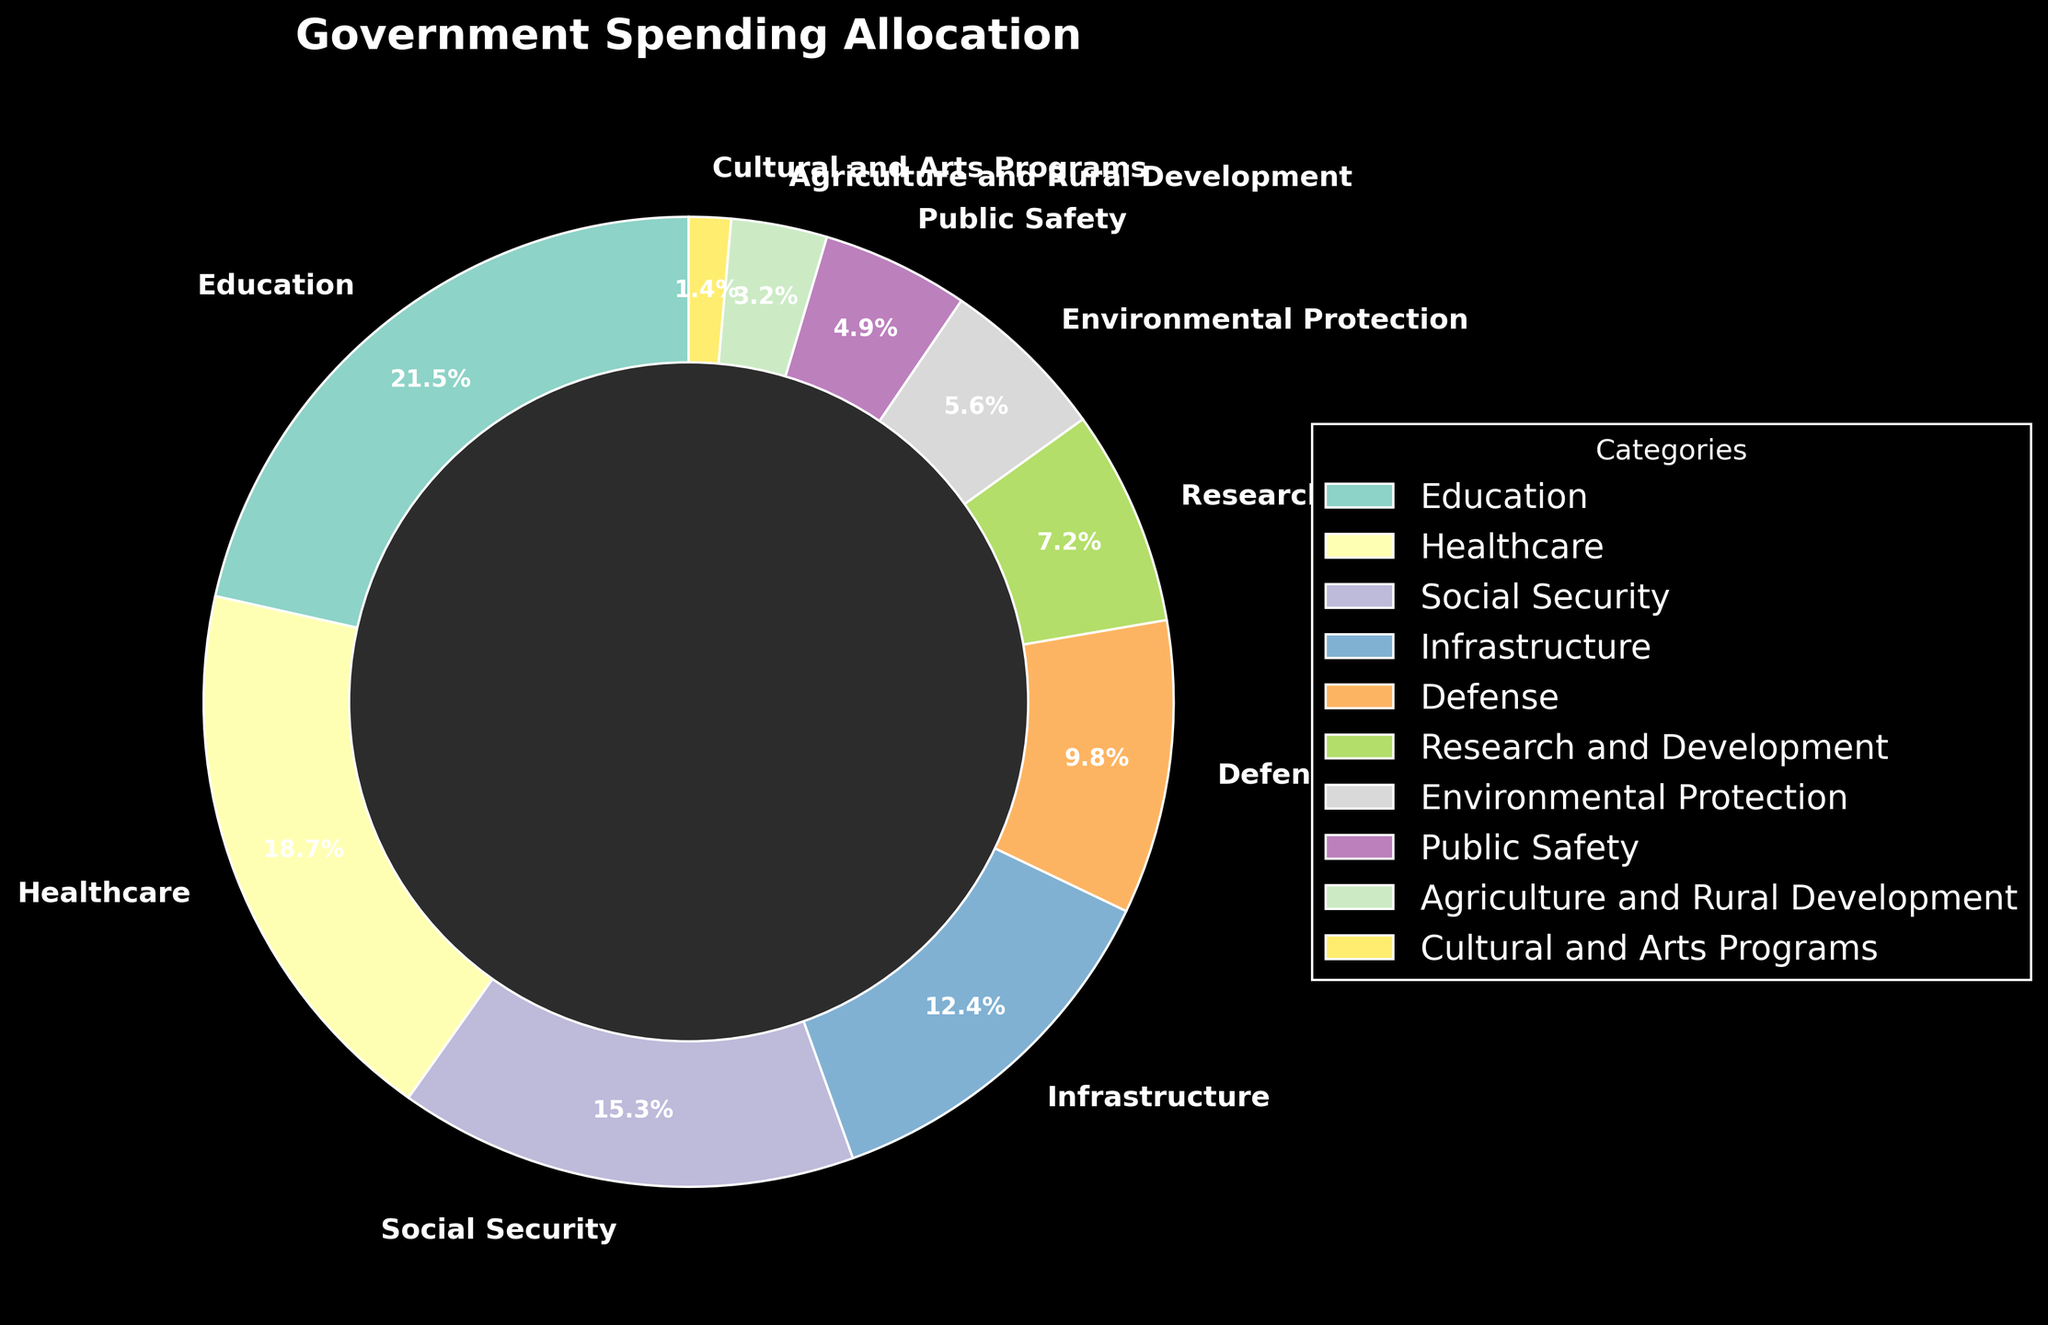Which category has the largest allocation? From the pie chart, Education has the largest segment which is labeled 21.5%.
Answer: Education Which two categories combined make up less than 10% of the total allocation? Cultural and Arts Programs (1.4%) and Agriculture and Rural Development (3.2%) together sum up to 4.6%, which is less than 10%.
Answer: Cultural and Arts Programs and Agriculture and Rural Development How much more is spent on Healthcare compared to Defense? Healthcare is 18.7% and Defense is 9.8%. The difference is 18.7% - 9.8% = 8.9%.
Answer: 8.9% What is the total percentage allocated to Environmental Protection and Public Safety? Environmental Protection is 5.6% and Public Safety is 4.9%. Summing these, 5.6% + 4.9% = 10.5%.
Answer: 10.5% Is the allocation for Social Security greater or less than the allocation for Research and Development? Social Security has an allocation of 15.3% whereas Research and Development has 7.2%. Therefore, Social Security's allocation is greater.
Answer: Greater Which categories have a combined allocation of over 50%? Adding the top categories: Education (21.5%), Healthcare (18.7%), and Social Security (15.3%) gives us 21.5% + 18.7% + 15.3% = 55.5%, which is over 50%.
Answer: Education, Healthcare, and Social Security How does the allocation for Infrastructure compare visually to the allocation for Defense? The pie chart shows Infrastructure with a larger segment (12.4%) compared to Defense (9.8%).
Answer: Infrastructure is larger What is the combined allocation of the smallest four categories? Adding the percentages for Cultural and Arts Programs (1.4%), Agriculture and Rural Development (3.2%), Public Safety (4.9%), and Environmental Protection (5.6%) gives 1.4% + 3.2% + 4.9% + 5.6% = 15.1%.
Answer: 15.1% Is the segment for Education larger or smaller than the combined segment of Defense and Research and Development? Education is 21.5%. Defense (9.8%) + Research and Development (7.2%) is 17%. Education's segment is larger.
Answer: Larger Which visual element makes the central part of the pie chart distinctive? The central part of the pie chart is more prominent due to a darker center circle, enhancing the visual focus on the segments.
Answer: Darker center circle 